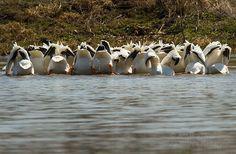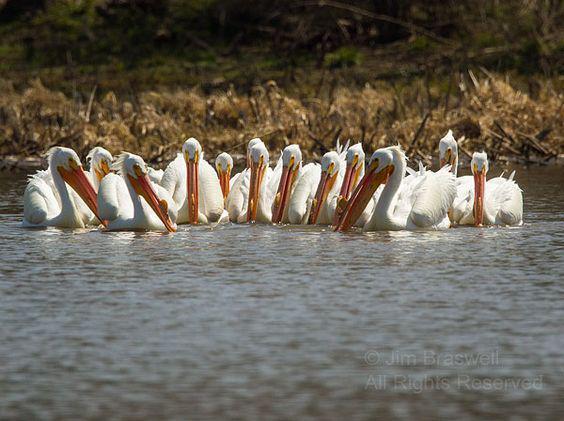The first image is the image on the left, the second image is the image on the right. Considering the images on both sides, is "In at least one photo, there are fewer than 5 birds." valid? Answer yes or no. No. The first image is the image on the left, the second image is the image on the right. Assess this claim about the two images: "There  are at least 20 pelicans with white feathers and orange beak sitting together with no water in sight.". Correct or not? Answer yes or no. No. 